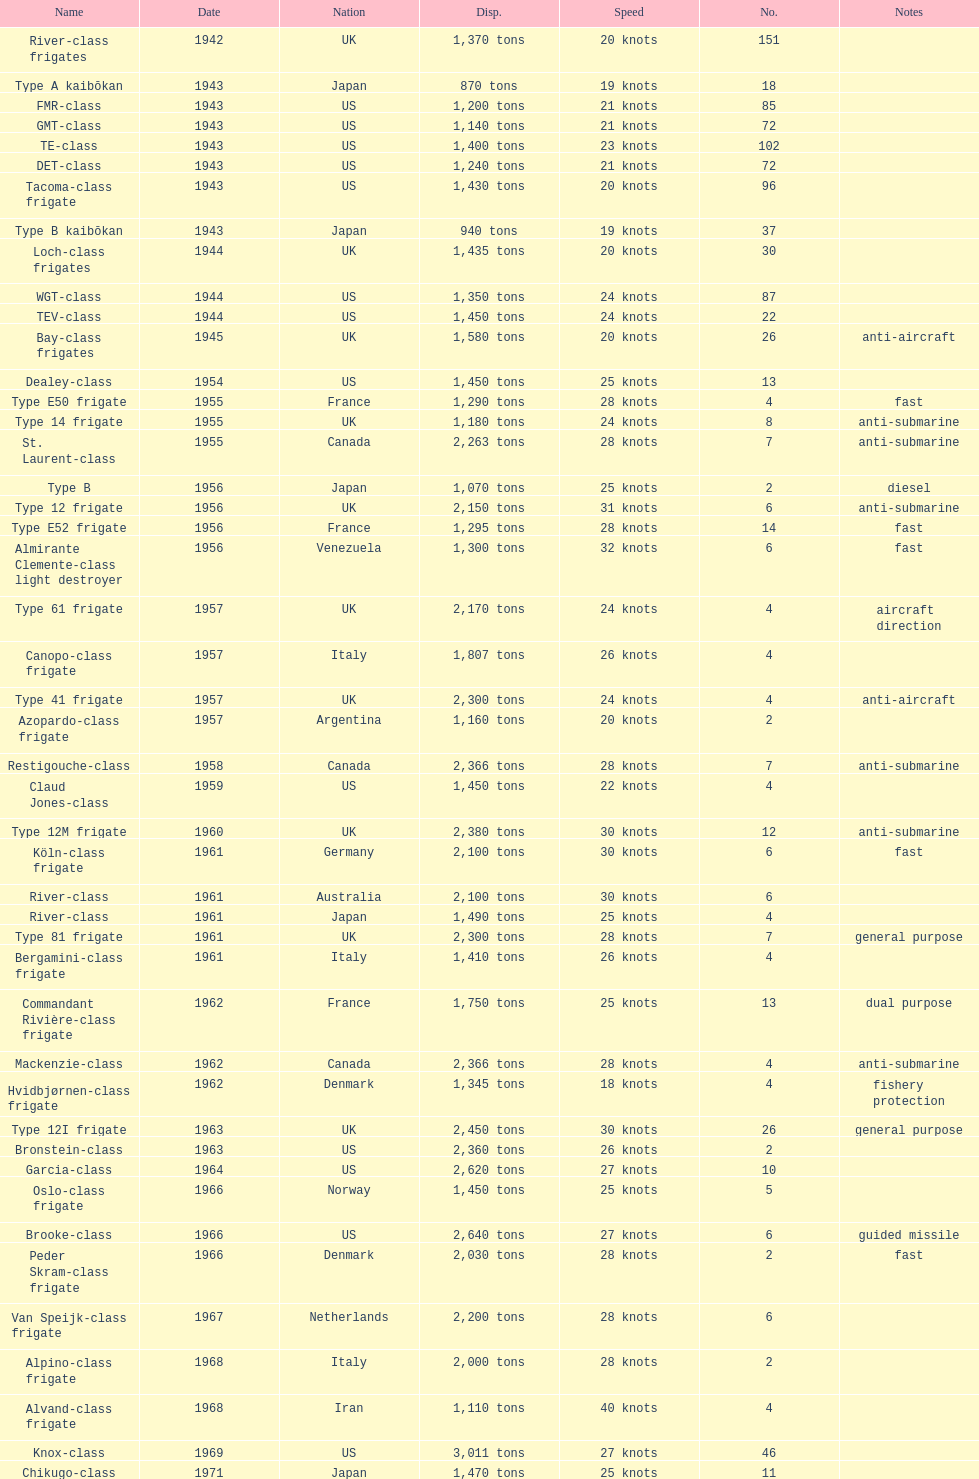In 1968 italy used alpino-class frigate. what was its top speed? 28 knots. 